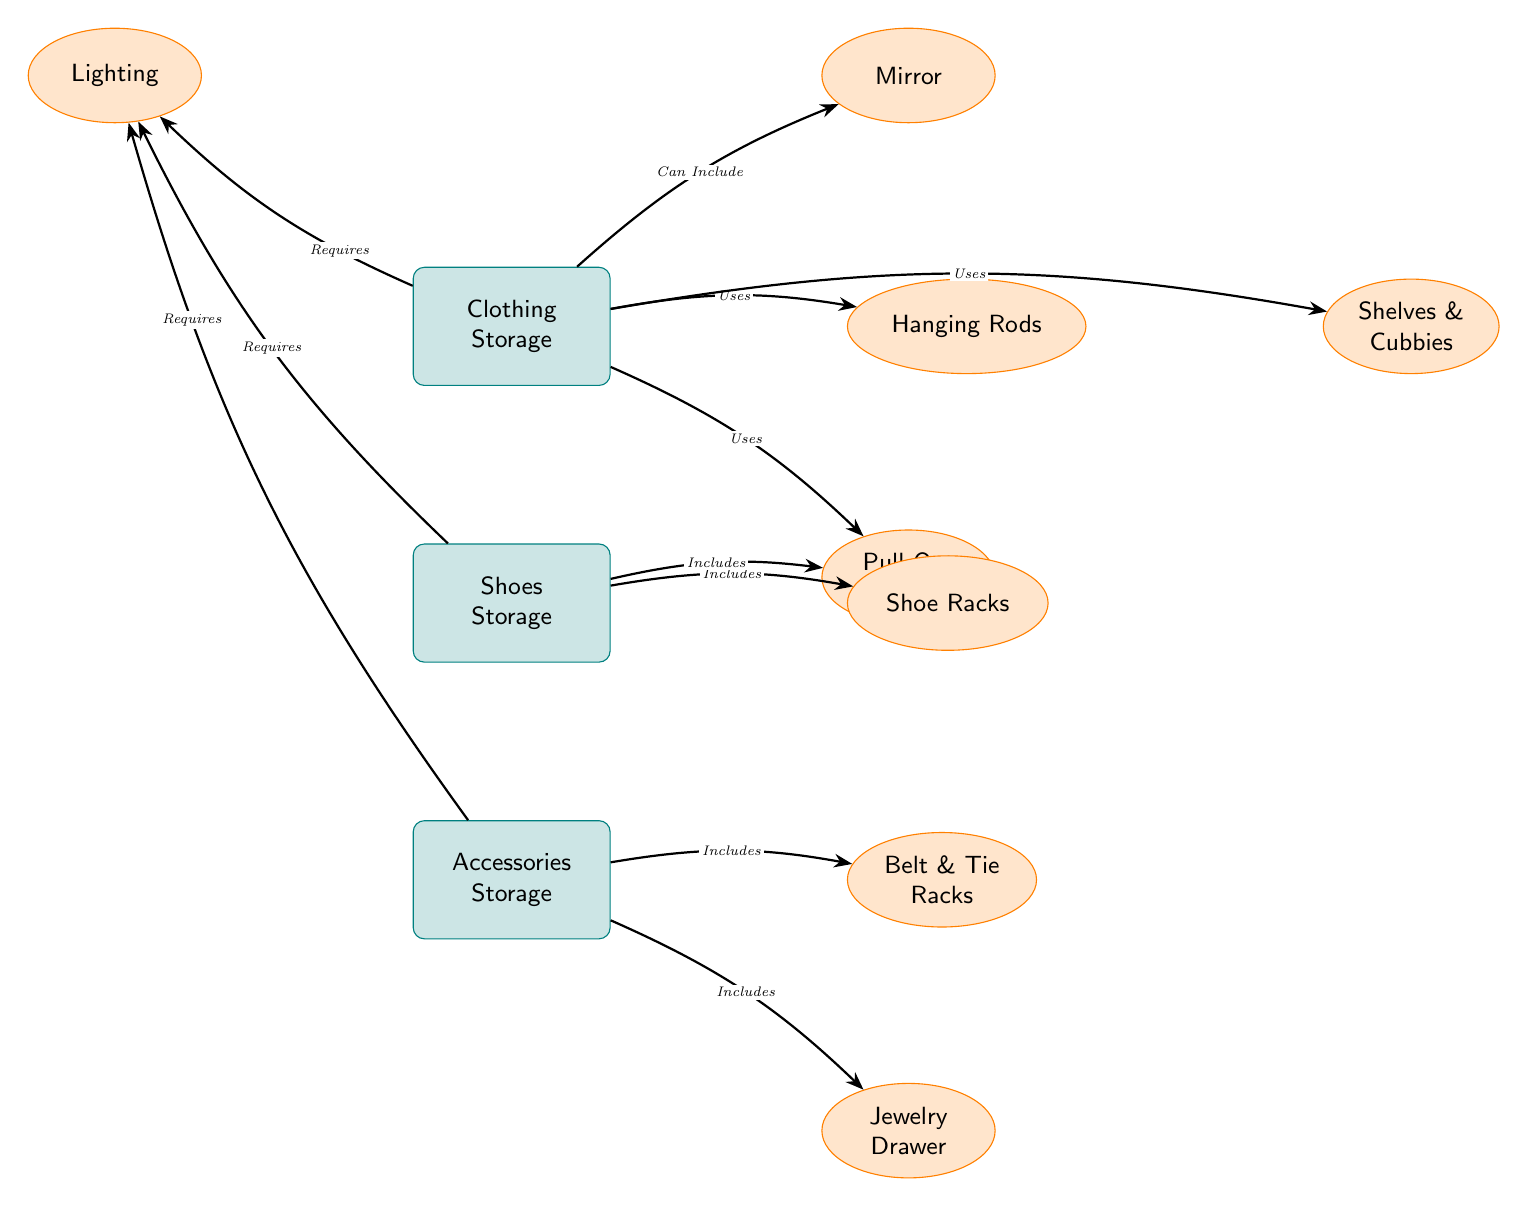What is the top node in the diagram? The top node is the first one visually depicted at the top of the diagram, which is "Clothing Storage."
Answer: Clothing Storage How many main storage types are represented in the diagram? The diagram has three main storage nodes: Clothing Storage, Shoes Storage, and Accessories Storage. Counting these gives a total of three main types.
Answer: 3 Which type of storage includes Pull-Out Drawers? By looking at the connections, "Pull-Out Drawers" is associated with both "Clothing Storage" and "Shoes Storage." Therefore, both can include Pull-Out Drawers.
Answer: Clothing Storage and Shoes Storage What types of storage require lighting? The arrows point from "Clothing Storage," "Shoes Storage," and "Accessories Storage" to the "Lighting" node, stating they all require it.
Answer: Clothing Storage, Shoes Storage, Accessories Storage How many secondary storage solutions are linked to Accessories Storage? The diagram shows two secondary nodes linked to "Accessories Storage": "Belt & Tie Racks" and "Jewelry Drawer." Therefore, there are two solutions.
Answer: 2 What function do Hanging Rods serve? The "Hanging Rods" node is connected to "Clothing Storage" with the label "Uses," indicating that it is a solution used for storing clothing.
Answer: Uses for clothing Which secondary node is connected to the Clothing Storage but not Shoes or Accessories Storage? The "Mirror" node is positioned above right of the "Clothing Storage," while it is not connected to any other main storage in the diagram, indicating its unique association.
Answer: Mirror How many edges connect to the Shoes Storage node? The "Shoes Storage" node has two edges: one leading to "Shoe Racks" and another to "Pull-Out Drawers," therefore it has a total of two connections.
Answer: 2 Which secondary storage solution does not require any additional features like lighting? "Shoe Racks" is directly connected to "Shoes Storage" without indicating any requirement for lighting, making it unique.
Answer: Shoe Racks What is a shared feature between Clothing and Accessories Storage? Both "Clothing Storage" and "Accessories Storage" include the requirement for "Lighting," indicating a shared feature between them.
Answer: Requires Lighting 